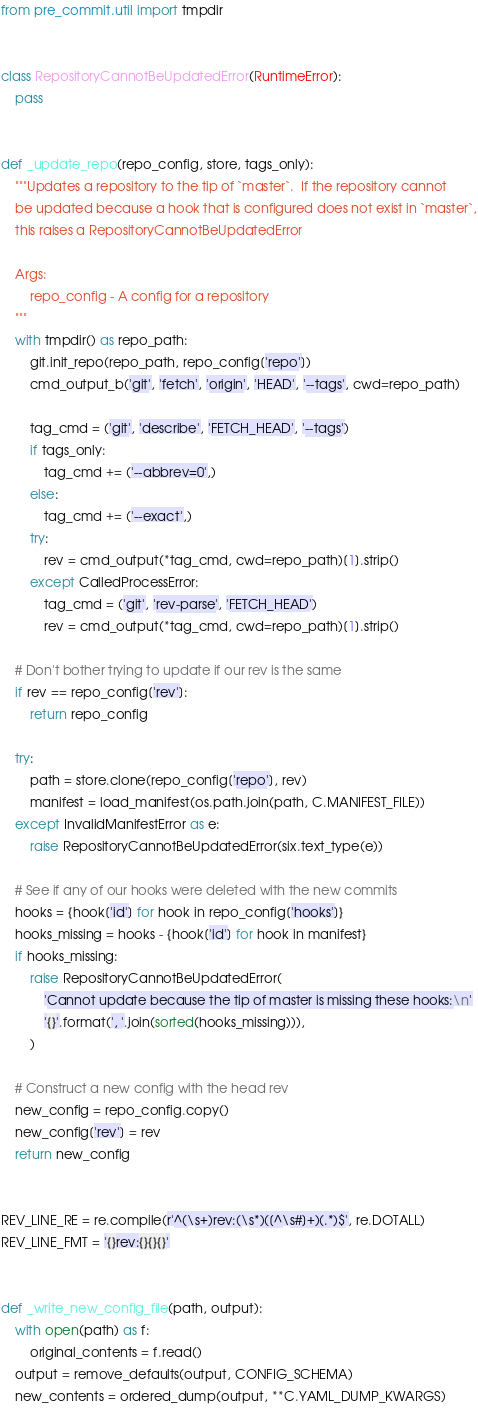Convert code to text. <code><loc_0><loc_0><loc_500><loc_500><_Python_>from pre_commit.util import tmpdir


class RepositoryCannotBeUpdatedError(RuntimeError):
    pass


def _update_repo(repo_config, store, tags_only):
    """Updates a repository to the tip of `master`.  If the repository cannot
    be updated because a hook that is configured does not exist in `master`,
    this raises a RepositoryCannotBeUpdatedError

    Args:
        repo_config - A config for a repository
    """
    with tmpdir() as repo_path:
        git.init_repo(repo_path, repo_config['repo'])
        cmd_output_b('git', 'fetch', 'origin', 'HEAD', '--tags', cwd=repo_path)

        tag_cmd = ('git', 'describe', 'FETCH_HEAD', '--tags')
        if tags_only:
            tag_cmd += ('--abbrev=0',)
        else:
            tag_cmd += ('--exact',)
        try:
            rev = cmd_output(*tag_cmd, cwd=repo_path)[1].strip()
        except CalledProcessError:
            tag_cmd = ('git', 'rev-parse', 'FETCH_HEAD')
            rev = cmd_output(*tag_cmd, cwd=repo_path)[1].strip()

    # Don't bother trying to update if our rev is the same
    if rev == repo_config['rev']:
        return repo_config

    try:
        path = store.clone(repo_config['repo'], rev)
        manifest = load_manifest(os.path.join(path, C.MANIFEST_FILE))
    except InvalidManifestError as e:
        raise RepositoryCannotBeUpdatedError(six.text_type(e))

    # See if any of our hooks were deleted with the new commits
    hooks = {hook['id'] for hook in repo_config['hooks']}
    hooks_missing = hooks - {hook['id'] for hook in manifest}
    if hooks_missing:
        raise RepositoryCannotBeUpdatedError(
            'Cannot update because the tip of master is missing these hooks:\n'
            '{}'.format(', '.join(sorted(hooks_missing))),
        )

    # Construct a new config with the head rev
    new_config = repo_config.copy()
    new_config['rev'] = rev
    return new_config


REV_LINE_RE = re.compile(r'^(\s+)rev:(\s*)([^\s#]+)(.*)$', re.DOTALL)
REV_LINE_FMT = '{}rev:{}{}{}'


def _write_new_config_file(path, output):
    with open(path) as f:
        original_contents = f.read()
    output = remove_defaults(output, CONFIG_SCHEMA)
    new_contents = ordered_dump(output, **C.YAML_DUMP_KWARGS)
</code> 